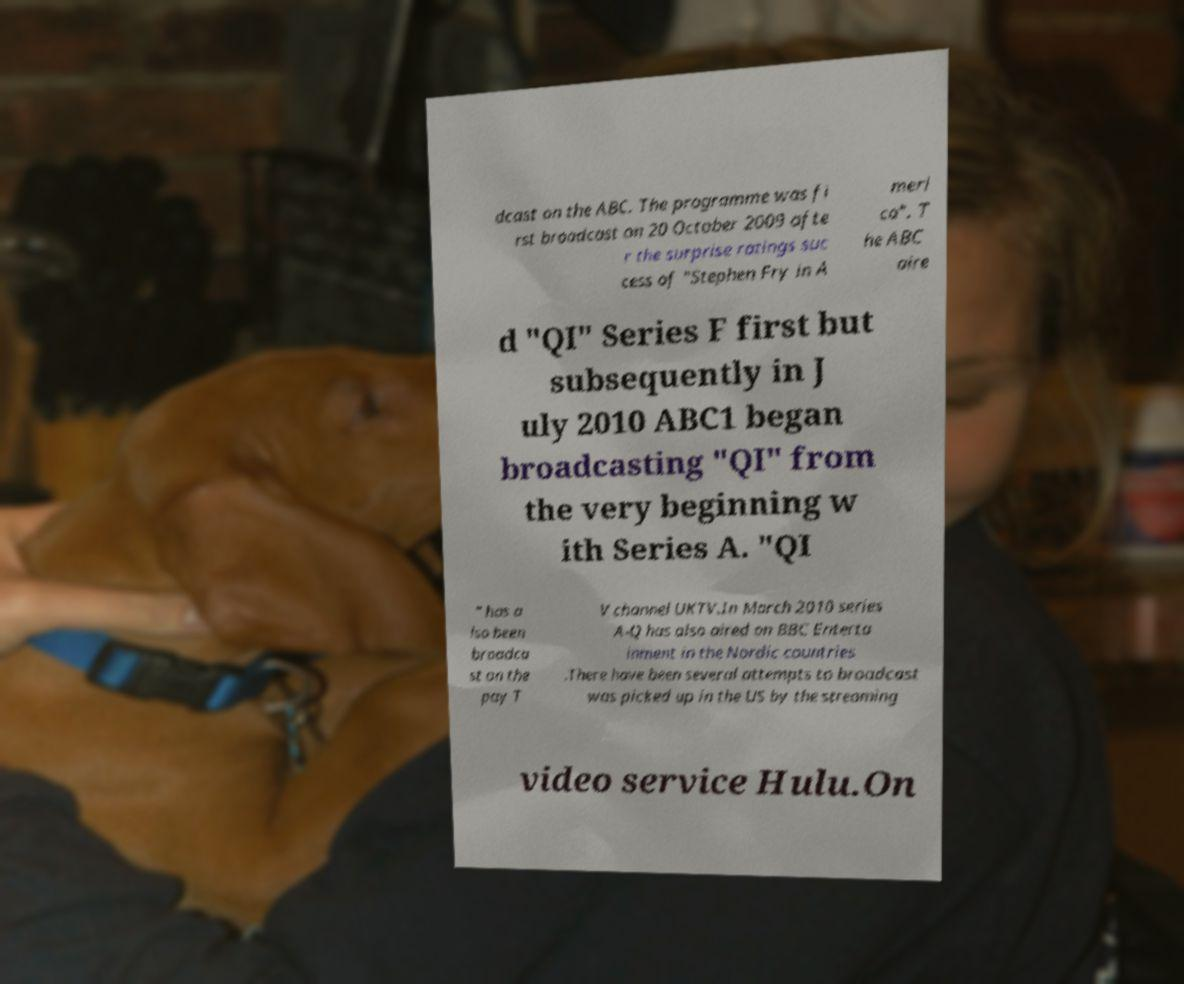I need the written content from this picture converted into text. Can you do that? dcast on the ABC. The programme was fi rst broadcast on 20 October 2009 afte r the surprise ratings suc cess of "Stephen Fry in A meri ca". T he ABC aire d "QI" Series F first but subsequently in J uly 2010 ABC1 began broadcasting "QI" from the very beginning w ith Series A. "QI " has a lso been broadca st on the pay T V channel UKTV.In March 2010 series A-Q has also aired on BBC Enterta inment in the Nordic countries .There have been several attempts to broadcast was picked up in the US by the streaming video service Hulu.On 